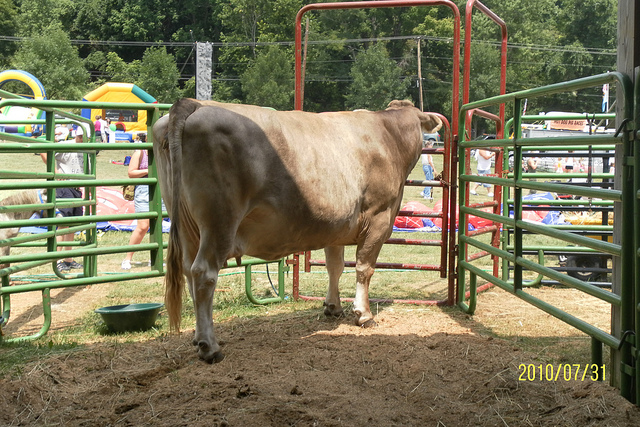Please identify all text content in this image. 2010/07/31 